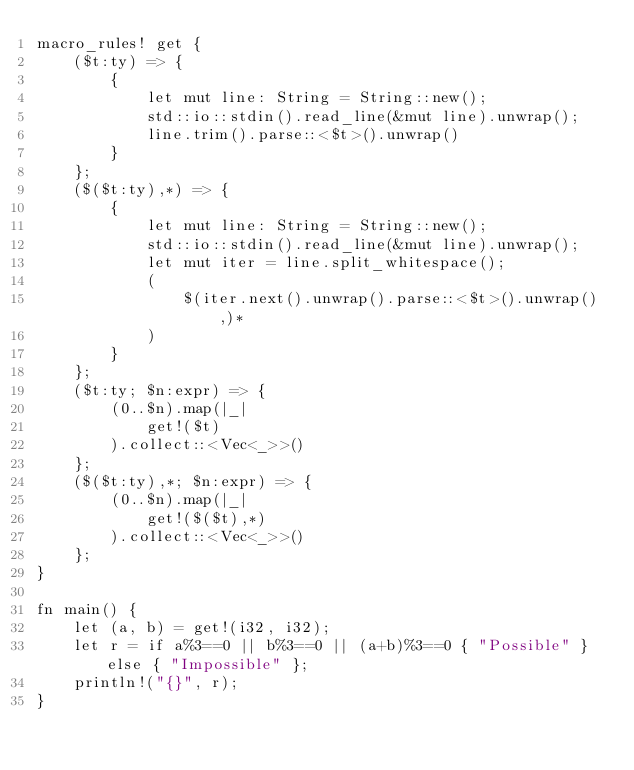Convert code to text. <code><loc_0><loc_0><loc_500><loc_500><_Rust_>macro_rules! get {
    ($t:ty) => {
        {
            let mut line: String = String::new();
            std::io::stdin().read_line(&mut line).unwrap();
            line.trim().parse::<$t>().unwrap()
        }
    };
    ($($t:ty),*) => {
        {
            let mut line: String = String::new();
            std::io::stdin().read_line(&mut line).unwrap();
            let mut iter = line.split_whitespace();
            (
                $(iter.next().unwrap().parse::<$t>().unwrap(),)*
            )
        }
    };
    ($t:ty; $n:expr) => {
        (0..$n).map(|_|
            get!($t)
        ).collect::<Vec<_>>()
    };
    ($($t:ty),*; $n:expr) => {
        (0..$n).map(|_|
            get!($($t),*)
        ).collect::<Vec<_>>()
    };
}

fn main() {
    let (a, b) = get!(i32, i32);
    let r = if a%3==0 || b%3==0 || (a+b)%3==0 { "Possible" } else { "Impossible" };
    println!("{}", r);
}</code> 